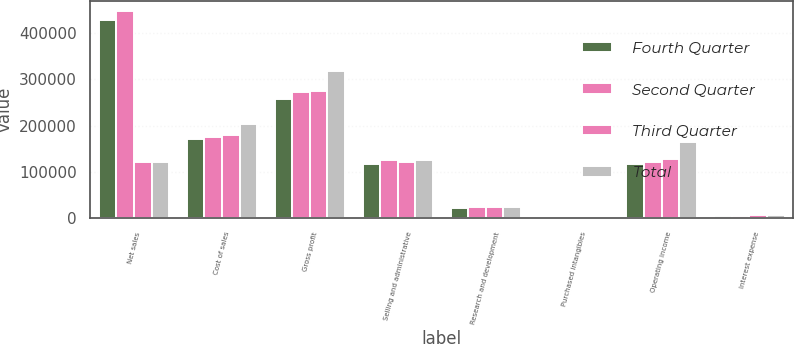<chart> <loc_0><loc_0><loc_500><loc_500><stacked_bar_chart><ecel><fcel>Net sales<fcel>Cost of sales<fcel>Gross profit<fcel>Selling and administrative<fcel>Research and development<fcel>Purchased intangibles<fcel>Operating income<fcel>Interest expense<nl><fcel>Fourth Quarter<fcel>427603<fcel>169829<fcel>257774<fcel>117124<fcel>22254<fcel>2501<fcel>115895<fcel>4083<nl><fcel>Second Quarter<fcel>447627<fcel>176103<fcel>271524<fcel>125439<fcel>23014<fcel>2504<fcel>120567<fcel>5052<nl><fcel>Third Quarter<fcel>120889<fcel>180318<fcel>274216<fcel>121211<fcel>23372<fcel>2369<fcel>127264<fcel>6159<nl><fcel>Total<fcel>120889<fcel>204243<fcel>317177<fcel>126237<fcel>23707<fcel>2359<fcel>164874<fcel>6677<nl></chart> 